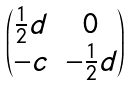Convert formula to latex. <formula><loc_0><loc_0><loc_500><loc_500>\begin{pmatrix} \frac { 1 } { 2 } d & 0 \\ - c & - \frac { 1 } { 2 } d \end{pmatrix}</formula> 